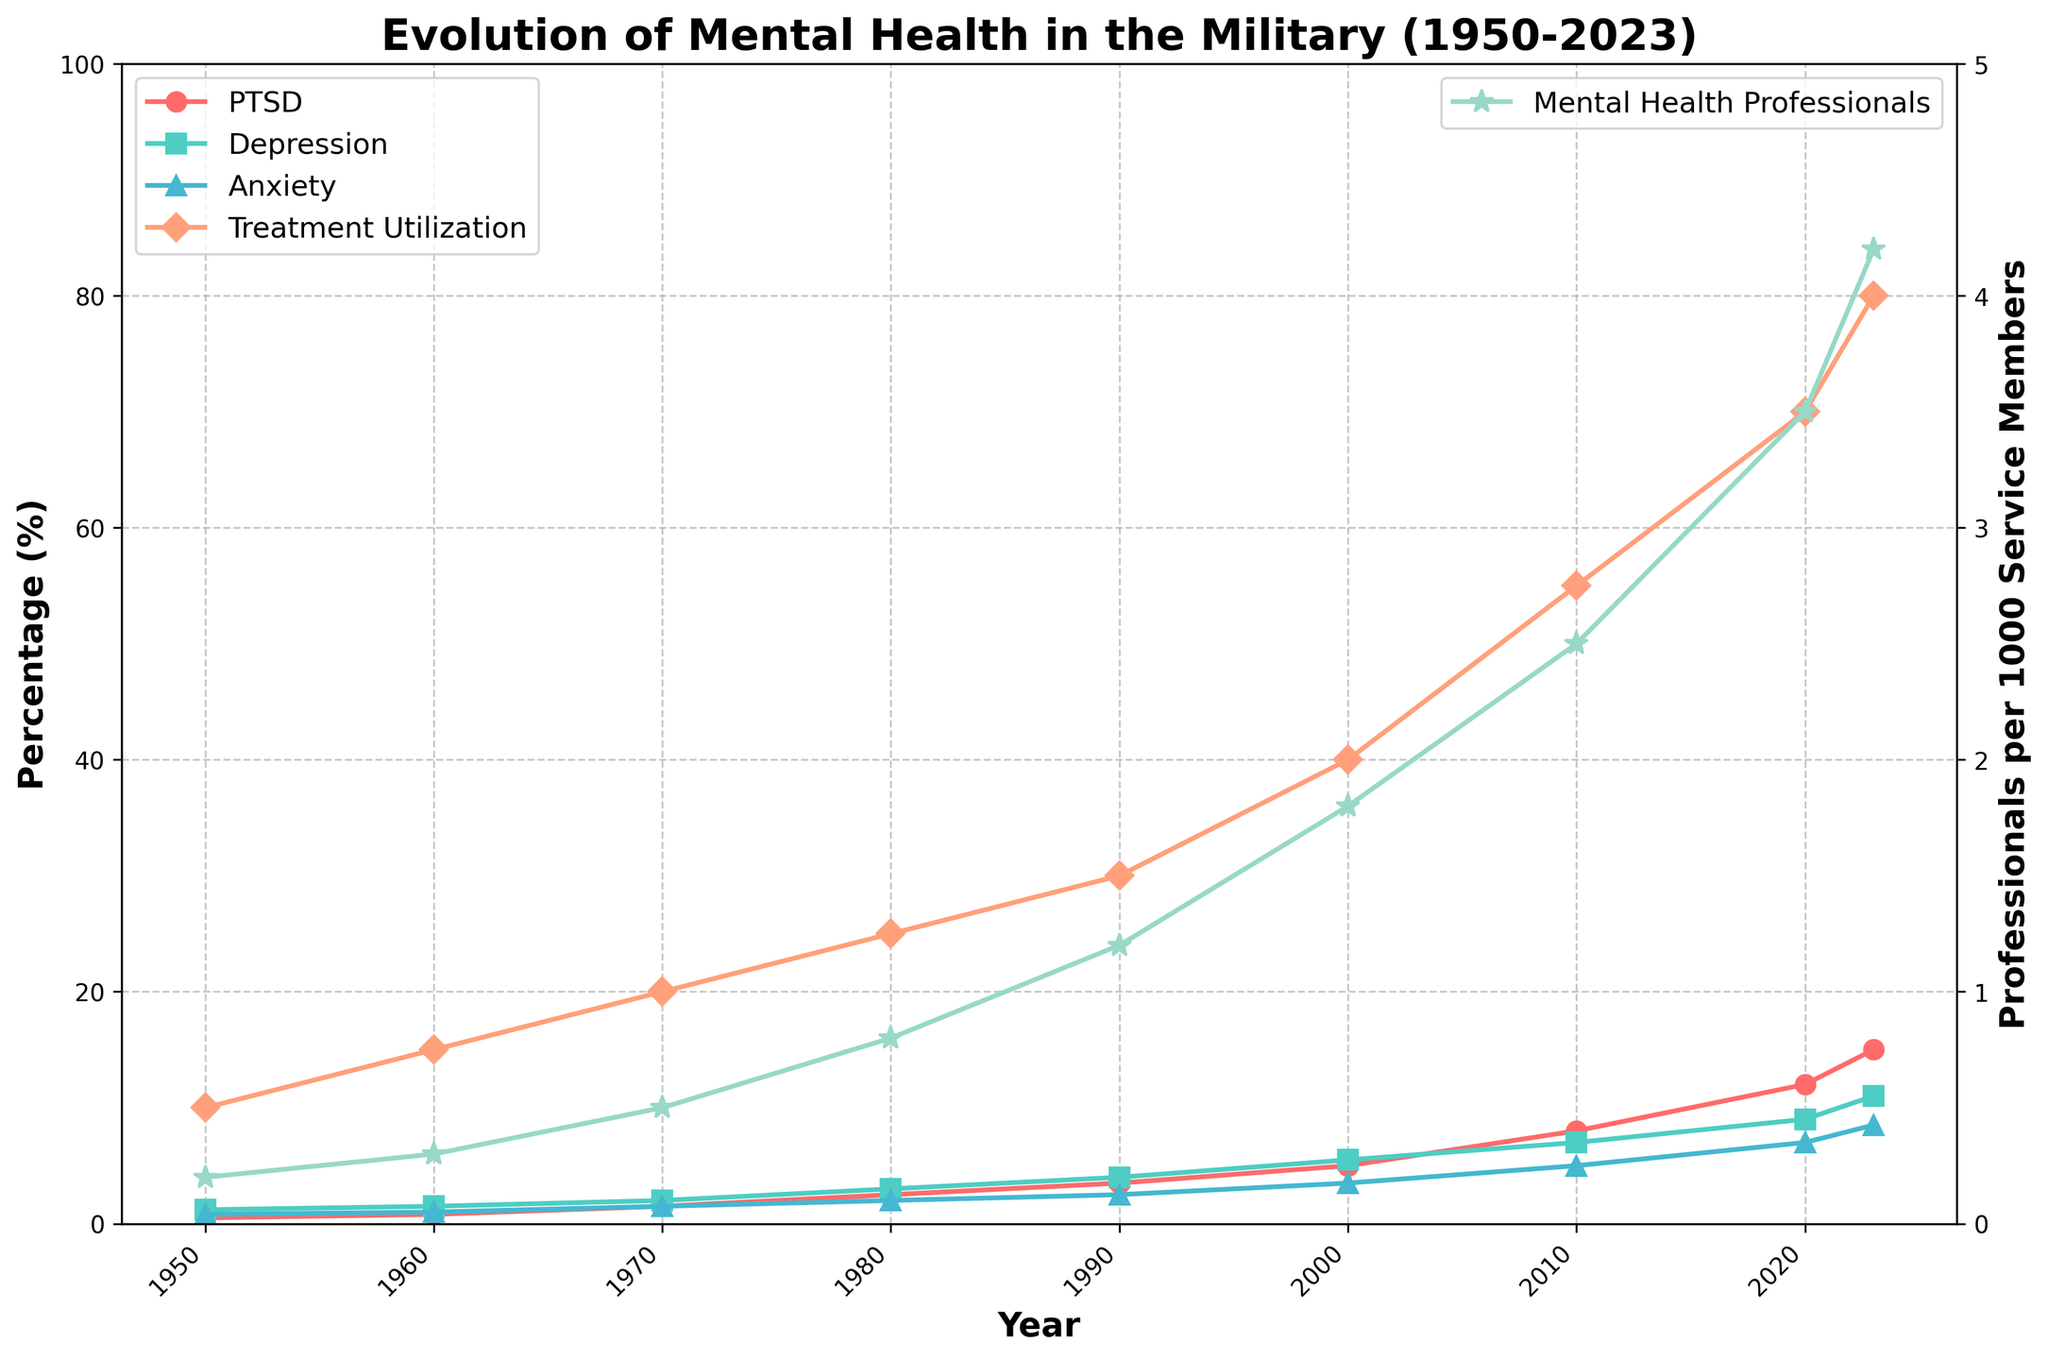What's the trend in the PTSD diagnosis rate from 1950 to 2023? The PTSD diagnosis rate has steadily increased over the years. Starting at 0.5% in 1950, it has risen significantly to reach 15.0% in 2023.
Answer: It has increased steadily Which year shows the highest rate of depression diagnosis? According to the figure, the highest rate of depression diagnosis occurs in 2023, with a value of 11.0%.
Answer: 2023 How does the trend in treatment utilization correlate with the number of mental health professionals per 1000 service members? Both treatment utilization and the number of mental health professionals per 1000 service members show a consistent upward trend over the years. As the number of mental health professionals increases, treatment utilization also rises, indicating a positive correlation.
Answer: Positive correlation In which decade did the anxiety diagnosis rate see the most significant increase? Analyzing the chart, the most significant increase in anxiety diagnosis rate occurred between 2000 and 2010. The rate jumped from 3.5% in 2000 to 5.0% in 2010.
Answer: Between 2000 and 2010 Compare the PTSD and depression diagnosis rates in 1980. Which is higher? In 1980, the PTSD diagnosis rate is 2.5%, while the depression diagnosis rate is 3.0%. Therefore, the depression diagnosis rate is higher.
Answer: Depression diagnosis rate What visual trend can be observed for the treatment utilization rate? The treatment utilization rate shows an upward trend, marked by a steady increase from 10% in 1950 to 80% in 2023. This indicates a significant increase in the utilization of mental health treatments over time.
Answer: Upward trend Calculate the average rate of increase in PTSD diagnosis from 2000 to 2023. The PTSD diagnosis rate in 2000 is 5.0%, and it increases to 15.0% by 2023. The rate of increase over these 23 years is (15.0% - 5.0%) / 23 ≈ 0.435% per year.
Answer: 0.435% per year Which year had the highest number of military mental health professionals per 1000 service members, and what was the value? The year 2023 had the highest number of military mental health professionals per 1000 service members, with a value of 4.2.
Answer: 2023, with 4.2 professionals Discuss the relationship between the increase in PTSD diagnosis and treatment utilization from 2000 to 2023. The PTSD diagnosis rate increased from 5.0% in 2000 to 15.0% in 2023, and during the same period, treatment utilization rose from 40% to 80%. This demonstrates that as the diagnosis rate of PTSD increased, there was also a substantial rise in the utilization of mental health treatment options.
Answer: Increase in both diagnosis rate and treatment utilization What's the difference in the anxiety diagnosis rate from 1960 to 2023? The anxiety diagnosis rate in 1960 is 1.0%, and it rises to 8.5% in 2023. The difference between these two rates is 8.5% - 1.0% = 7.5%.
Answer: 7.5% 